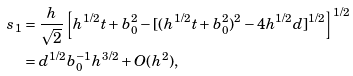<formula> <loc_0><loc_0><loc_500><loc_500>s _ { 1 } & = \frac { h } { \sqrt { 2 } } \left [ h ^ { 1 / 2 } t + b _ { 0 } ^ { 2 } - [ ( h ^ { 1 / 2 } t + b _ { 0 } ^ { 2 } ) ^ { 2 } - 4 h ^ { 1 / 2 } d ] ^ { 1 / 2 } \right ] ^ { 1 / 2 } \\ & = d ^ { 1 / 2 } b ^ { - 1 } _ { 0 } h ^ { 3 / 2 } + O ( h ^ { 2 } ) ,</formula> 